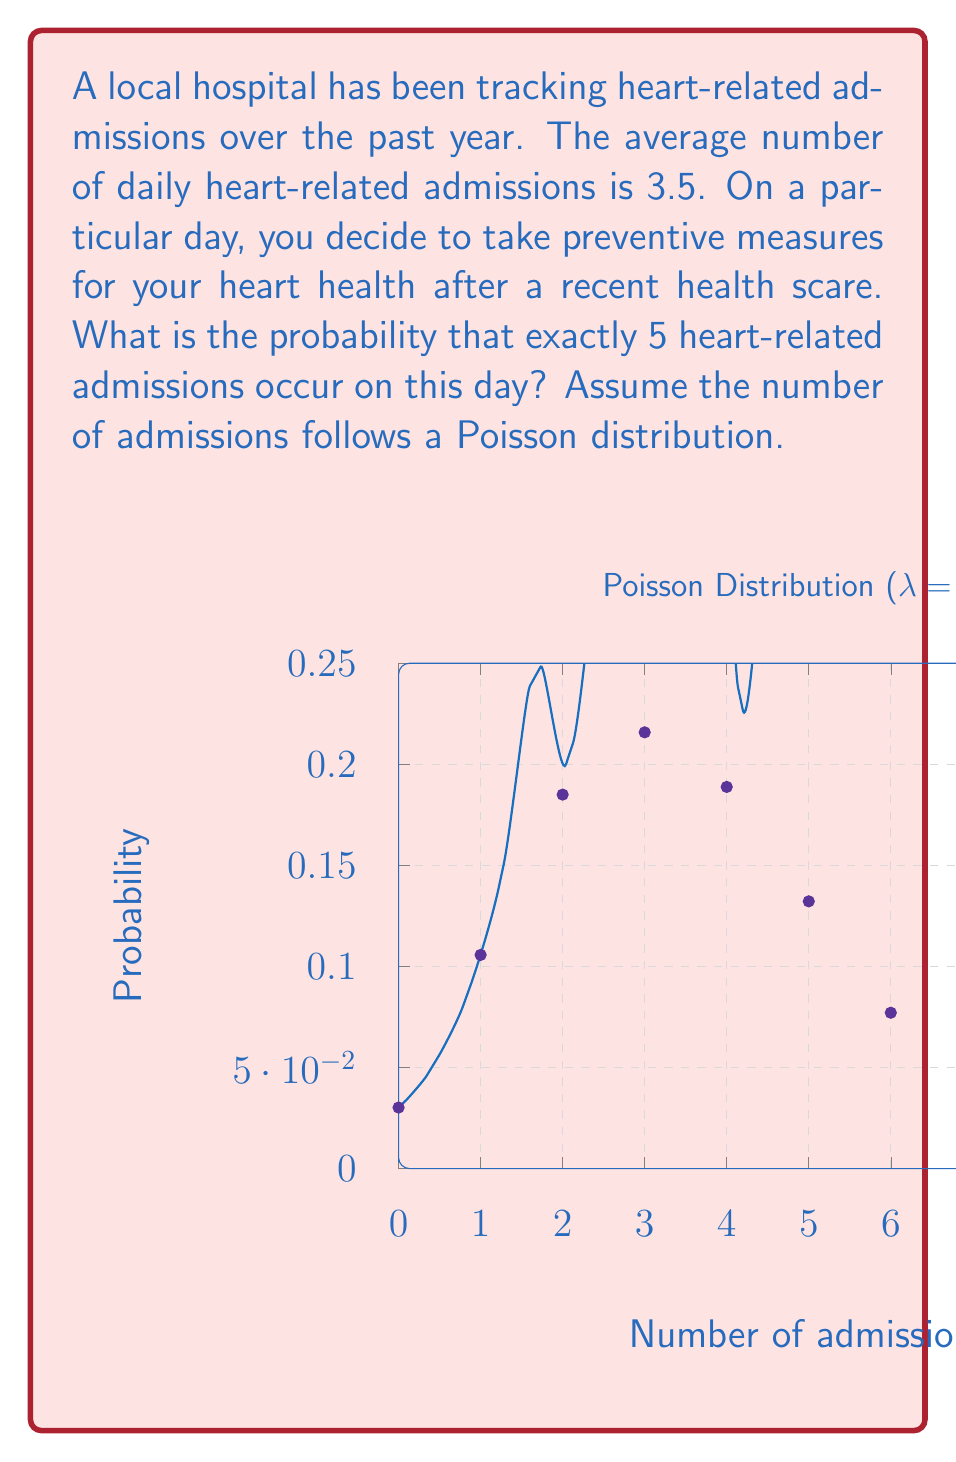Help me with this question. To solve this problem, we'll use the Poisson distribution formula:

$$ P(X = k) = \frac{e^{-\lambda} \lambda^k}{k!} $$

Where:
- $\lambda$ is the average rate of occurrences (in this case, 3.5 admissions per day)
- $k$ is the number of occurrences we're interested in (in this case, 5 admissions)
- $e$ is Euler's number (approximately 2.71828)

Let's plug in the values:

$$ P(X = 5) = \frac{e^{-3.5} 3.5^5}{5!} $$

Step 1: Calculate $e^{-3.5}$
$e^{-3.5} \approx 0.0302419$

Step 2: Calculate $3.5^5$
$3.5^5 = 525.21875$

Step 3: Calculate $5!$
$5! = 5 \times 4 \times 3 \times 2 \times 1 = 120$

Step 4: Put it all together
$$ P(X = 5) = \frac{0.0302419 \times 525.21875}{120} \approx 0.1317 $$

Therefore, the probability of exactly 5 heart-related admissions on this day is approximately 0.1317 or 13.17%.
Answer: $0.1317$ or $13.17\%$ 